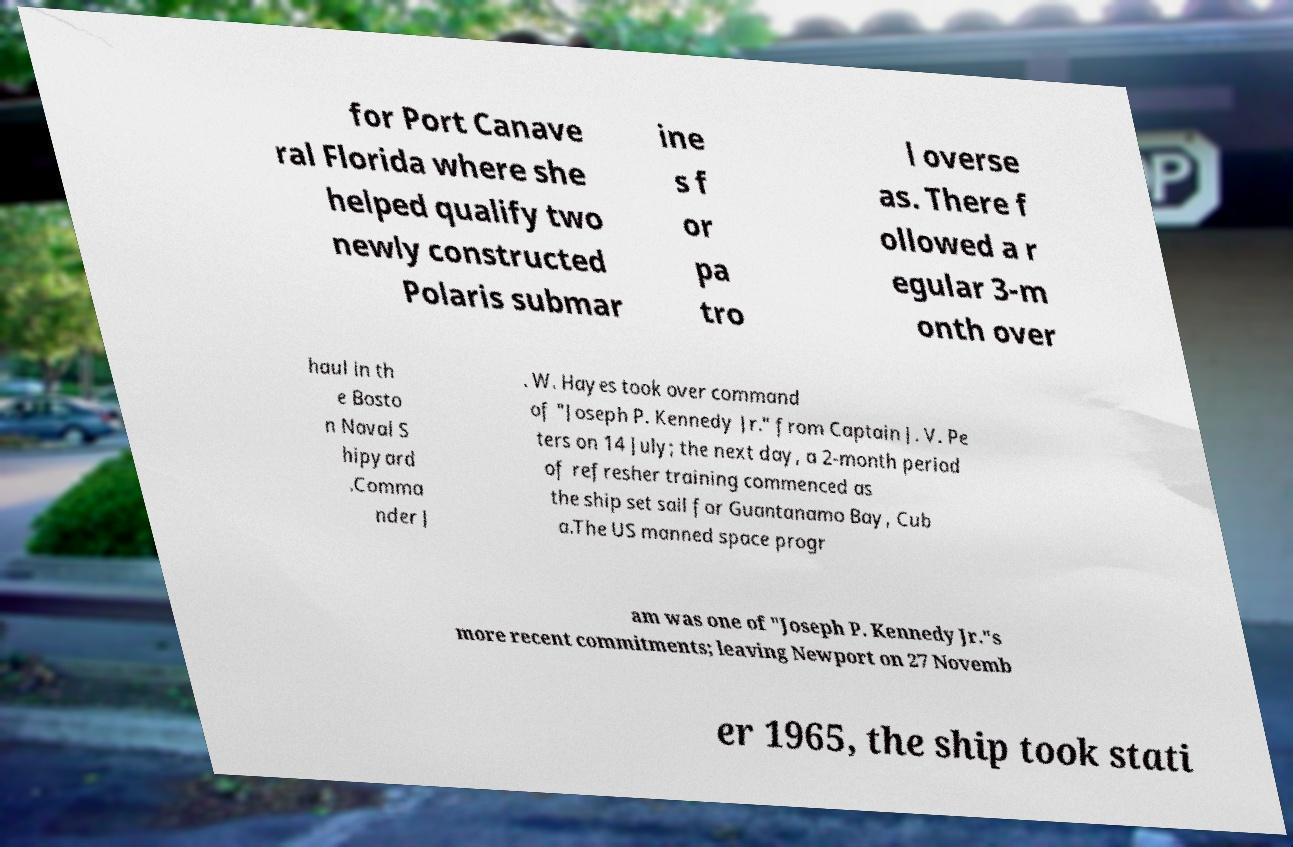I need the written content from this picture converted into text. Can you do that? for Port Canave ral Florida where she helped qualify two newly constructed Polaris submar ine s f or pa tro l overse as. There f ollowed a r egular 3-m onth over haul in th e Bosto n Naval S hipyard .Comma nder J . W. Hayes took over command of "Joseph P. Kennedy Jr." from Captain J. V. Pe ters on 14 July; the next day, a 2-month period of refresher training commenced as the ship set sail for Guantanamo Bay, Cub a.The US manned space progr am was one of "Joseph P. Kennedy Jr."s more recent commitments; leaving Newport on 27 Novemb er 1965, the ship took stati 